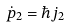<formula> <loc_0><loc_0><loc_500><loc_500>\dot { p } _ { 2 } = \hbar { j } _ { 2 }</formula> 